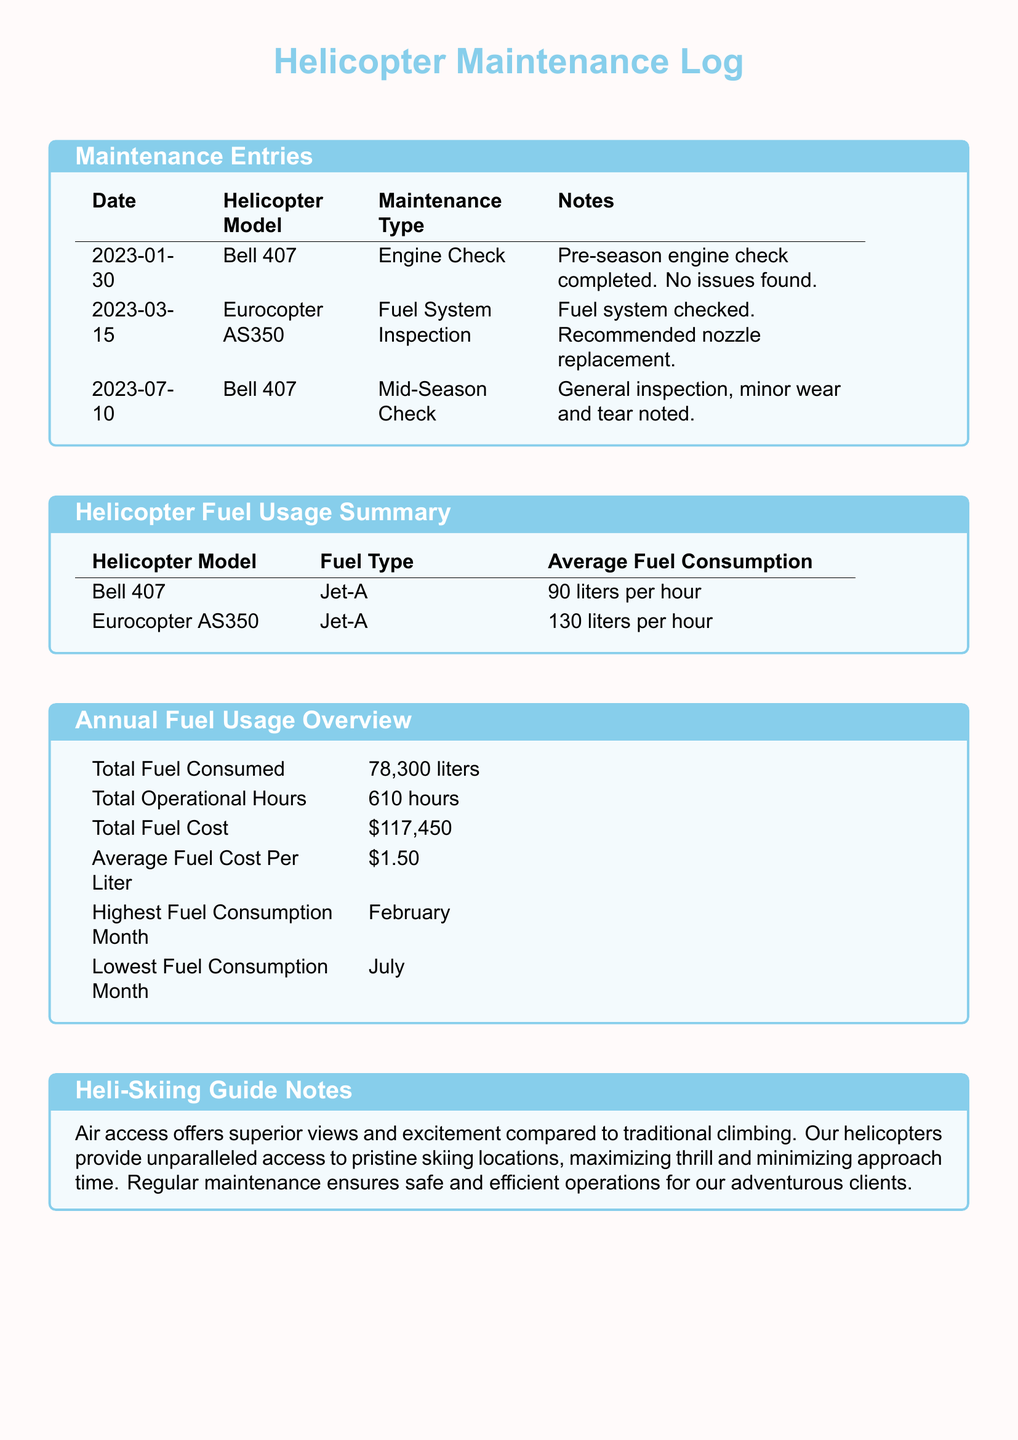What is the highest fuel consumption month? The highest fuel consumption month is reported in the annual fuel usage overview section of the document.
Answer: February What is the average fuel consumption of the Eurocopter AS350? The average fuel consumption for the Eurocopter AS350 is listed in the fuel usage summary section.
Answer: 130 liters per hour How much was the total fuel cost? The total fuel cost is provided in the annual fuel usage overview table.
Answer: $117,450 What type of maintenance was performed on January 30, 2023? The type of maintenance for January 30, 2023, is mentioned in the maintenance entries section of the document.
Answer: Engine Check What is the average fuel cost per liter? The average fuel cost per liter is available in the annual fuel usage overview.
Answer: $1.50 Which helicopter model has lower average fuel consumption? To determine which model has lower average fuel consumption, we can compare the figures from the fuel usage summary.
Answer: Bell 407 What was the total fuel consumed throughout the year? The total fuel consumed is summarized in the annual fuel usage overview.
Answer: 78,300 liters What maintenance recommendation was made for the Eurocopter AS350? The maintenance recommendation for the Eurocopter AS350 is included in the notes for the fuel system inspection.
Answer: Nozzle replacement What model had a mid-season check? The model that had a mid-season check is specified in the maintenance entries section.
Answer: Bell 407 